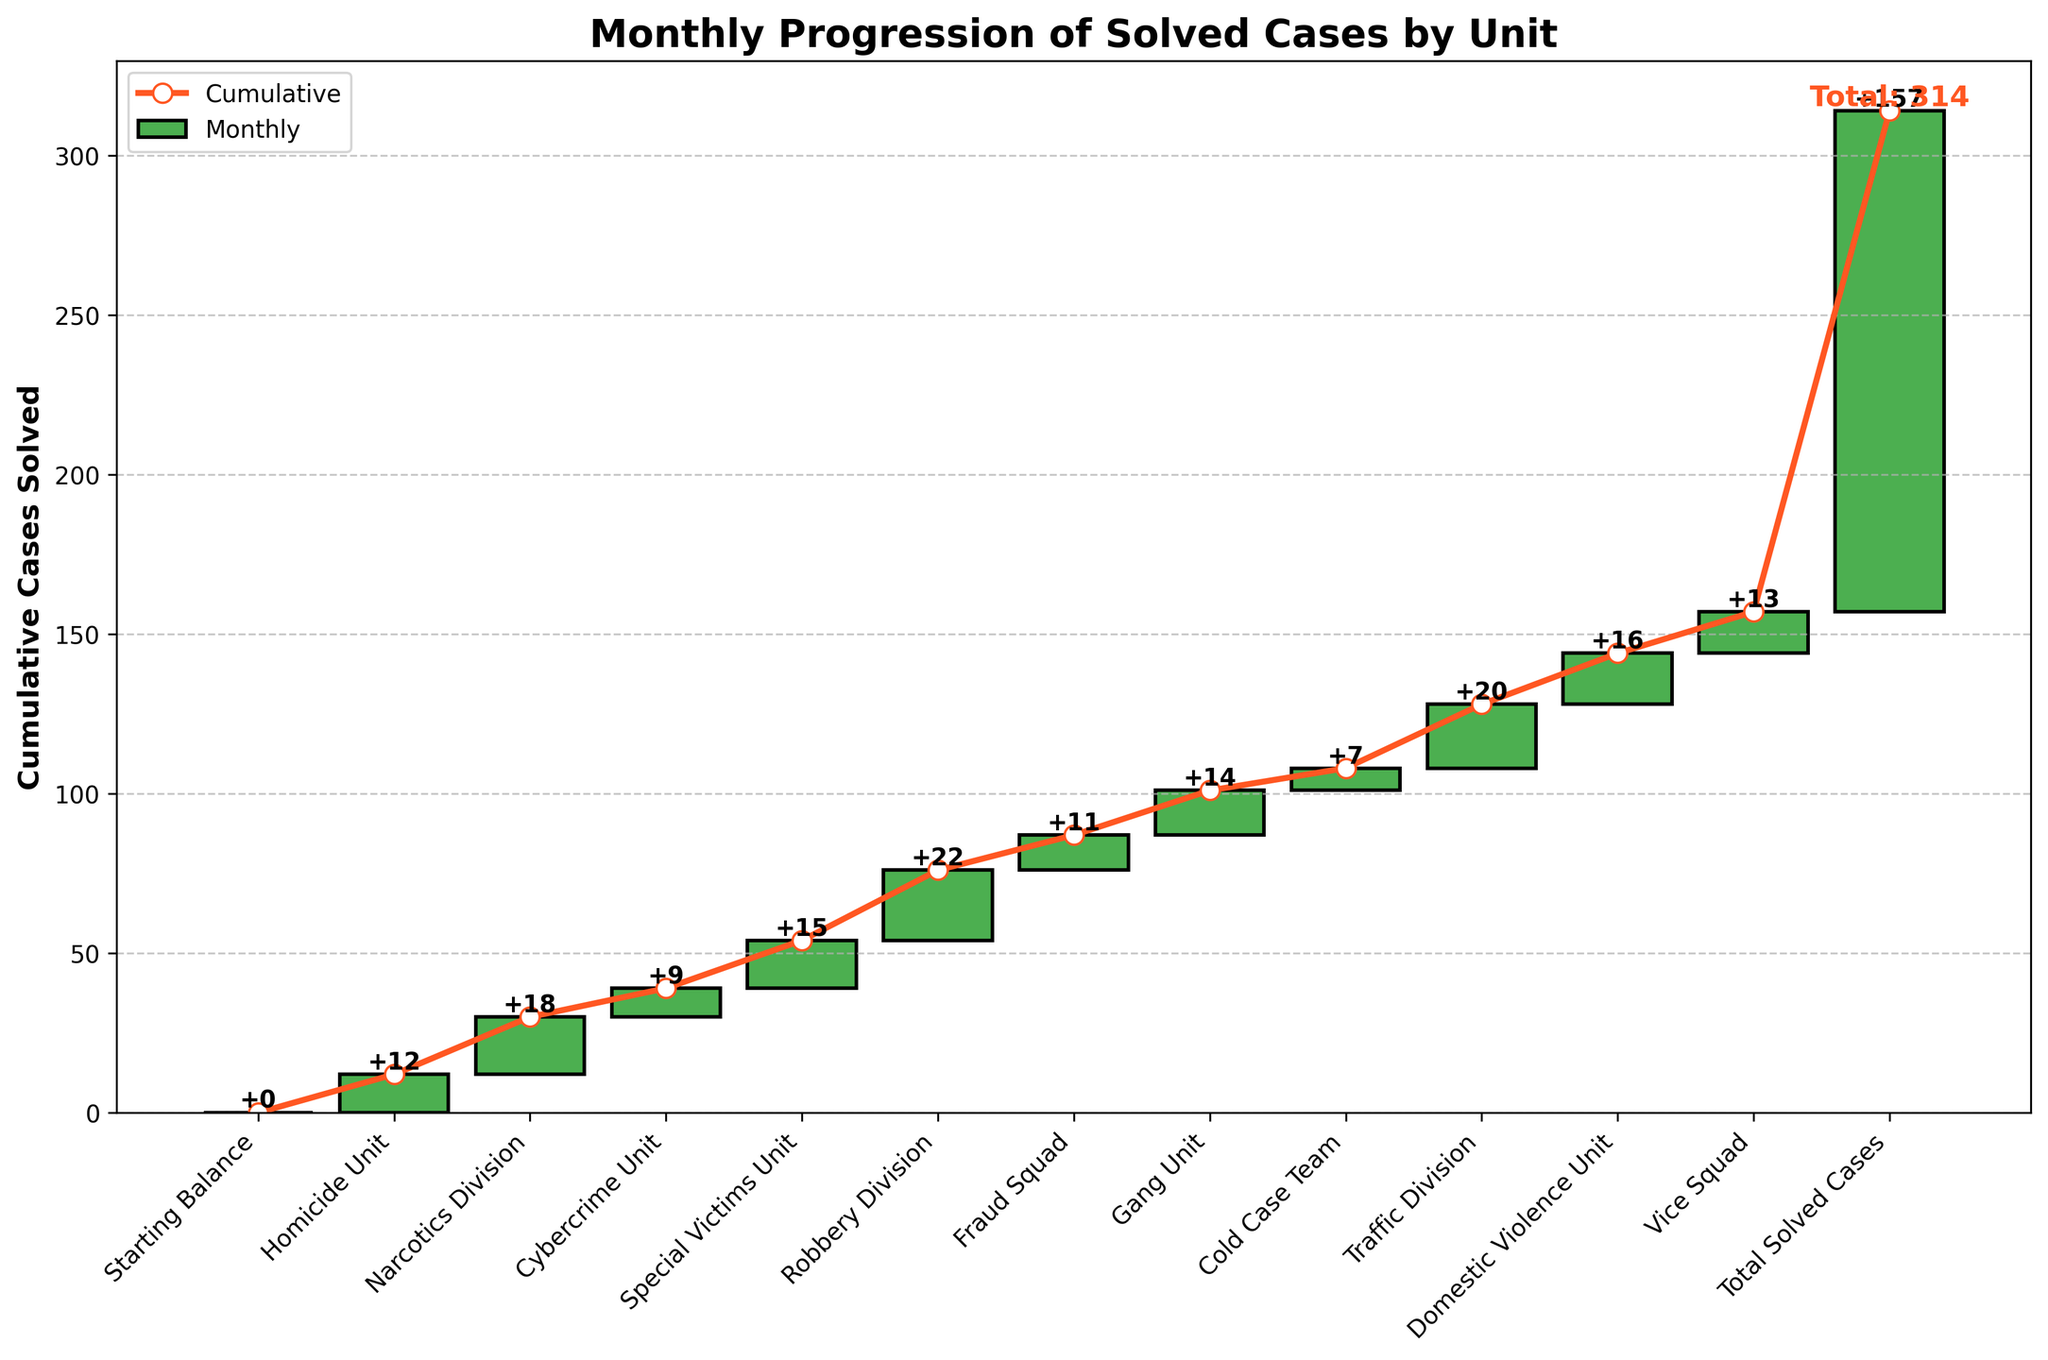What is the title of the figure? The title is located at the top of the chart, indicating the main subject of the figure, which is "Monthly Progression of Solved Cases by Unit."
Answer: Monthly Progression of Solved Cases by Unit What do the bars represent in the figure? The bars represent the number of cases solved by each unit in each month. They are stacked to show cumulative progress over the months.
Answer: The number of cases solved by each unit per month How many cases were solved by the Homicide Unit in February? To find this, locate the bar corresponding to the Homicide Unit and read the value. The Homicide Unit solved 12 cases.
Answer: 12 Which unit solved the most cases in a single month? By comparing the height of all bars, the Robbery Division has the highest value at 22 cases.
Answer: Robbery Division What is the cumulative number of cases solved by the end of June? Sum the values for each month from January to June. This consists of February (12), March (18), April (9), May (15), and June (22). Adding these gives 76 cases.
Answer: 76 How does the number of cases solved by the Cybercrime Unit compare to the Special Victims Unit? Compare the heights of the bars for the Cybercrime Unit and the Special Victims Unit. Cybercrime solved 9 cases, and Special Victims solved 15 cases. The Special Victims Unit solved more cases than the Cybercrime Unit.
Answer: The Special Victims Unit solved more cases What are the cumulative cases solved by the end of December? Look at the final cumulative value, indicated at the end of the plot. The total is 157 cases.
Answer: 157 Which unit contributed to the cumulative line steepest rise, and what was the contribution? Identify the unit with the highest number of cases solved in a single month by comparing the vertical jumps. The Robbery Division had the steepest rise with 22 cases.
Answer: Robbery Division, 22 cases What units solved cases in June through August, and how many did each solve? Read the respective bars for June (Robbery Division, 22), July (Fraud Squad, 11), and August (Gang Unit, 14).
Answer: Robbery Division - 22, Fraud Squad - 11, Gang Unit - 14 By what amount did the Cold Case Team’s solved cases change the trajectory on the plot? The Cold Case Team contributed with 7 cases, which can be observed by the height of their respective bar.
Answer: 7 